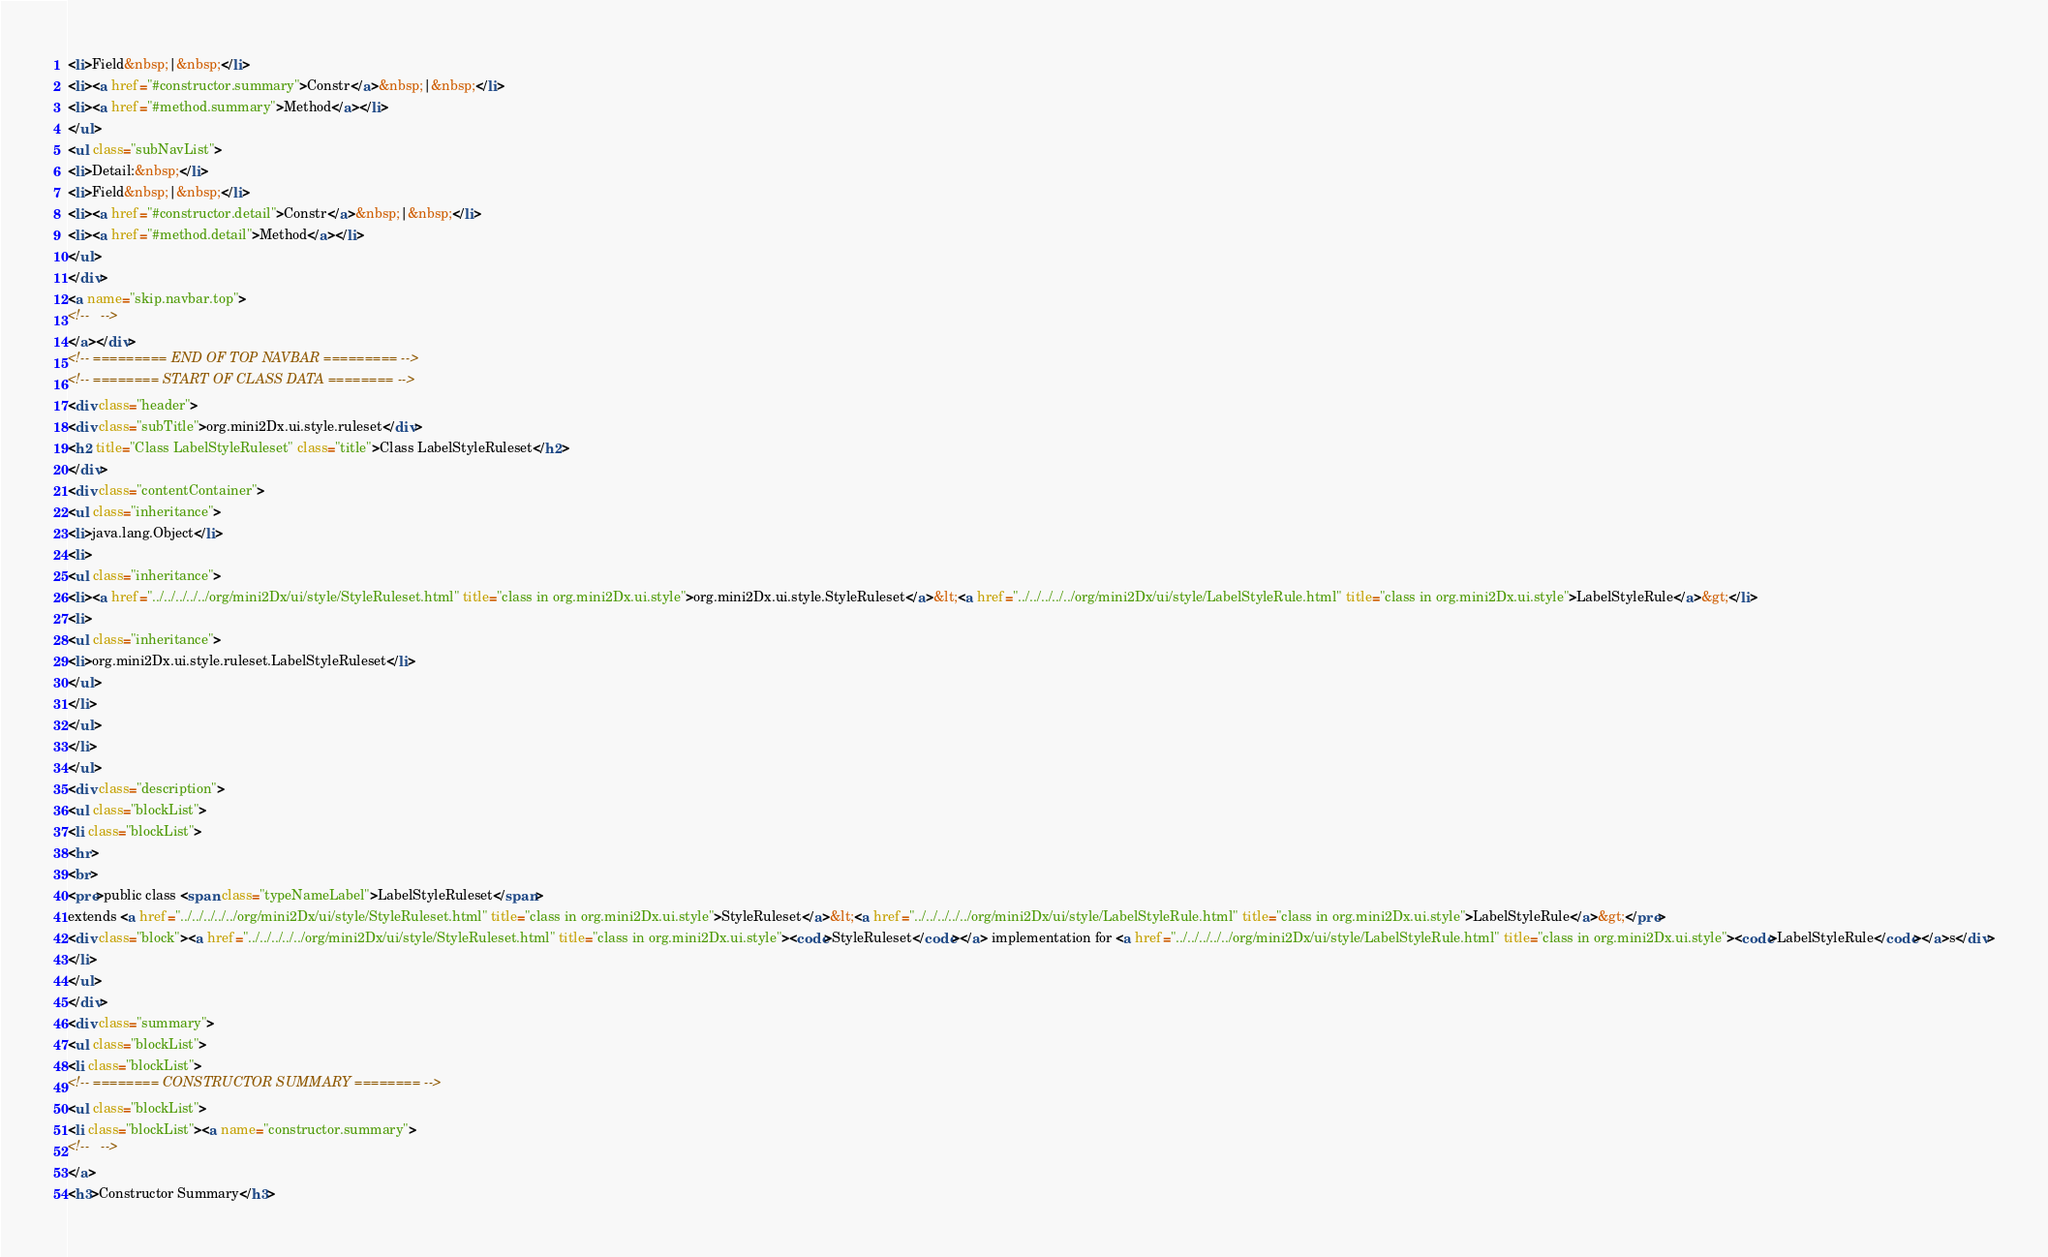Convert code to text. <code><loc_0><loc_0><loc_500><loc_500><_HTML_><li>Field&nbsp;|&nbsp;</li>
<li><a href="#constructor.summary">Constr</a>&nbsp;|&nbsp;</li>
<li><a href="#method.summary">Method</a></li>
</ul>
<ul class="subNavList">
<li>Detail:&nbsp;</li>
<li>Field&nbsp;|&nbsp;</li>
<li><a href="#constructor.detail">Constr</a>&nbsp;|&nbsp;</li>
<li><a href="#method.detail">Method</a></li>
</ul>
</div>
<a name="skip.navbar.top">
<!--   -->
</a></div>
<!-- ========= END OF TOP NAVBAR ========= -->
<!-- ======== START OF CLASS DATA ======== -->
<div class="header">
<div class="subTitle">org.mini2Dx.ui.style.ruleset</div>
<h2 title="Class LabelStyleRuleset" class="title">Class LabelStyleRuleset</h2>
</div>
<div class="contentContainer">
<ul class="inheritance">
<li>java.lang.Object</li>
<li>
<ul class="inheritance">
<li><a href="../../../../../org/mini2Dx/ui/style/StyleRuleset.html" title="class in org.mini2Dx.ui.style">org.mini2Dx.ui.style.StyleRuleset</a>&lt;<a href="../../../../../org/mini2Dx/ui/style/LabelStyleRule.html" title="class in org.mini2Dx.ui.style">LabelStyleRule</a>&gt;</li>
<li>
<ul class="inheritance">
<li>org.mini2Dx.ui.style.ruleset.LabelStyleRuleset</li>
</ul>
</li>
</ul>
</li>
</ul>
<div class="description">
<ul class="blockList">
<li class="blockList">
<hr>
<br>
<pre>public class <span class="typeNameLabel">LabelStyleRuleset</span>
extends <a href="../../../../../org/mini2Dx/ui/style/StyleRuleset.html" title="class in org.mini2Dx.ui.style">StyleRuleset</a>&lt;<a href="../../../../../org/mini2Dx/ui/style/LabelStyleRule.html" title="class in org.mini2Dx.ui.style">LabelStyleRule</a>&gt;</pre>
<div class="block"><a href="../../../../../org/mini2Dx/ui/style/StyleRuleset.html" title="class in org.mini2Dx.ui.style"><code>StyleRuleset</code></a> implementation for <a href="../../../../../org/mini2Dx/ui/style/LabelStyleRule.html" title="class in org.mini2Dx.ui.style"><code>LabelStyleRule</code></a>s</div>
</li>
</ul>
</div>
<div class="summary">
<ul class="blockList">
<li class="blockList">
<!-- ======== CONSTRUCTOR SUMMARY ======== -->
<ul class="blockList">
<li class="blockList"><a name="constructor.summary">
<!--   -->
</a>
<h3>Constructor Summary</h3></code> 